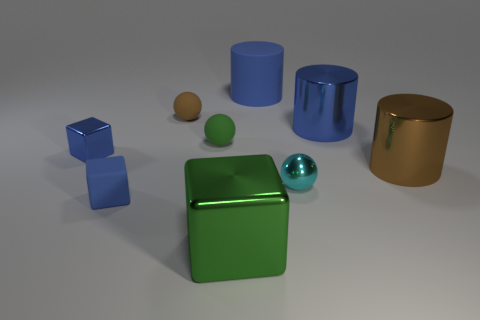What is the color composition of the scene? Do any two objects share the same color? The color composition of the scene includes blue, brown, green, and golden hues, with teal and tan as additional colors for the spherical objects. None of the uniquely shaped objects share the exact same color, but both spheres have a similar shade of tan, albeit with varying brightness.  Without counting the reflective surfaces, how many distinct colors are present in the objects? Excluding the reflective surfaces, there are four distinct colors present in the objects: blue for the cubes, brown for the tall cylinder, green for the cube in the center, and gold for the cylindrical object on the right. The spheres introduce a tan and a teal color, which could be seen as distinct if we consider their difference in saturation and brightness. 